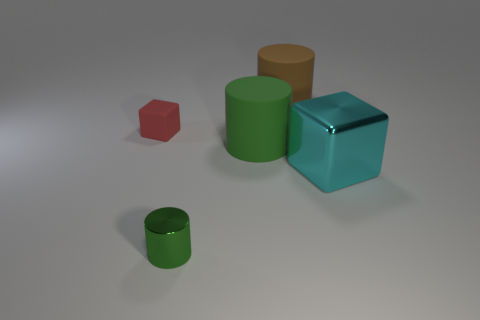Are there fewer red rubber cubes that are on the left side of the small green metallic object than big shiny cubes that are behind the big brown matte cylinder?
Offer a very short reply. No. How many objects are either red things or tiny blue matte cylinders?
Make the answer very short. 1. There is a small red cube; what number of tiny green cylinders are behind it?
Your answer should be very brief. 0. The brown object that is made of the same material as the tiny block is what shape?
Offer a terse response. Cylinder. There is a small green shiny object that is in front of the small red matte thing; is it the same shape as the big brown object?
Provide a short and direct response. Yes. How many gray objects are small metallic things or cylinders?
Keep it short and to the point. 0. Are there an equal number of metal blocks that are right of the cyan metal object and green shiny cylinders that are in front of the matte block?
Ensure brevity in your answer.  No. What is the color of the large cylinder in front of the big cylinder that is right of the matte cylinder in front of the big brown matte thing?
Offer a very short reply. Green. Are there any other things that are the same color as the tiny metal object?
Give a very brief answer. Yes. The matte thing that is the same color as the small cylinder is what shape?
Give a very brief answer. Cylinder. 